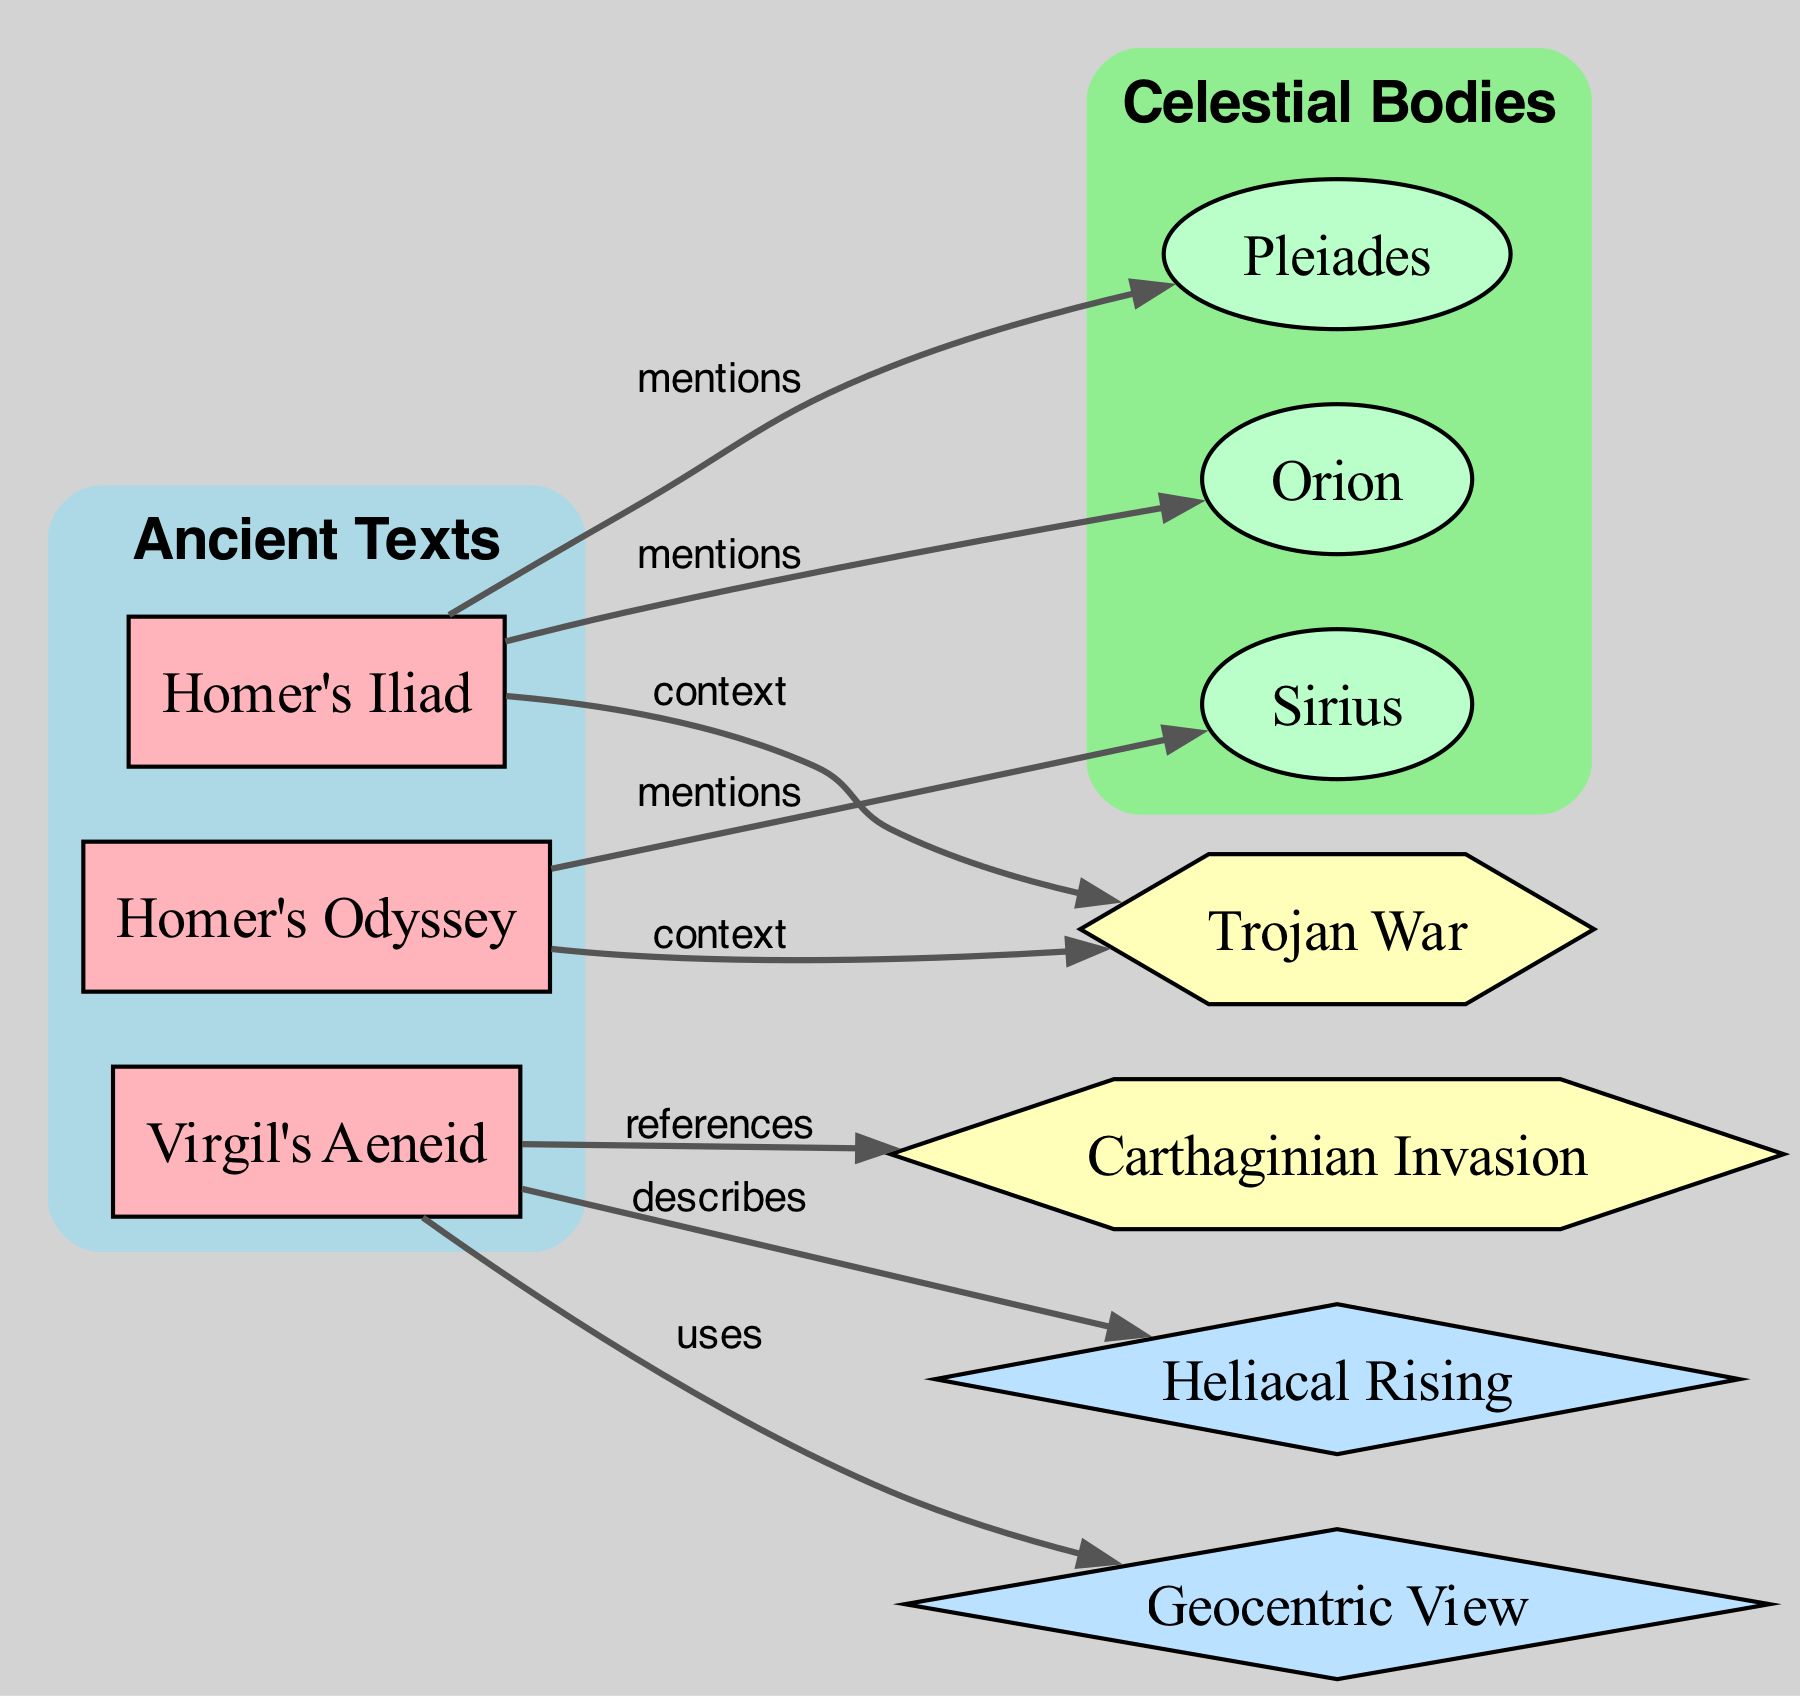What ancient text mentions Orion? By reviewing the relationships in the diagram, we see an edge labeled "mentions" connecting "Homer's Iliad" to "Orion."
Answer: Homer’s Iliad How many edges are in the diagram? Counting the edges, we find 8 connections between the nodes in the diagram.
Answer: 8 Which astronomical body is described in Virgil's Aeneid? The diagram indicates that Virgil's Aeneid has a relationship labeled "describes" connected to "Heliacal Rising," indicating that this concept is presented in the text.
Answer: Heliacal Rising What type of view is used in Virgil's Aeneid? The diagram shows a relationship labeled "uses" connecting Virgil's Aeneid to "Geocentric View," meaning this perspective is employed in the narrative.
Answer: Geocentric View Which historical event is referenced in Virgil's Aeneid? The diagram illustrates an edge labeled "references" that connects Virgil's Aeneid to "Carthaginian Invasion," indicating this event is mentioned in the text.
Answer: Carthaginian Invasion What celestial body is mentioned in both Homer’s Iliad and Homer’s Odyssey? Analyzing the edges, we see that both texts have edges connecting to "Orion" and "Sirius," demonstrating their mentions in these ancient texts.
Answer: Sirius What is the relationship type between Homer’s Odyssey and Sirius? Looking at the diagram, the relationship is indicated as "mentions," which shows that the text makes reference to this star.
Answer: mentions In which context is the Trojan War mentioned relative to Homer’s Iliad? The diagram depicts an edge labeled "context" connecting Homer’s Iliad to "Trojan War," indicating that the war serves as a backdrop for the narratives in the text.
Answer: context 